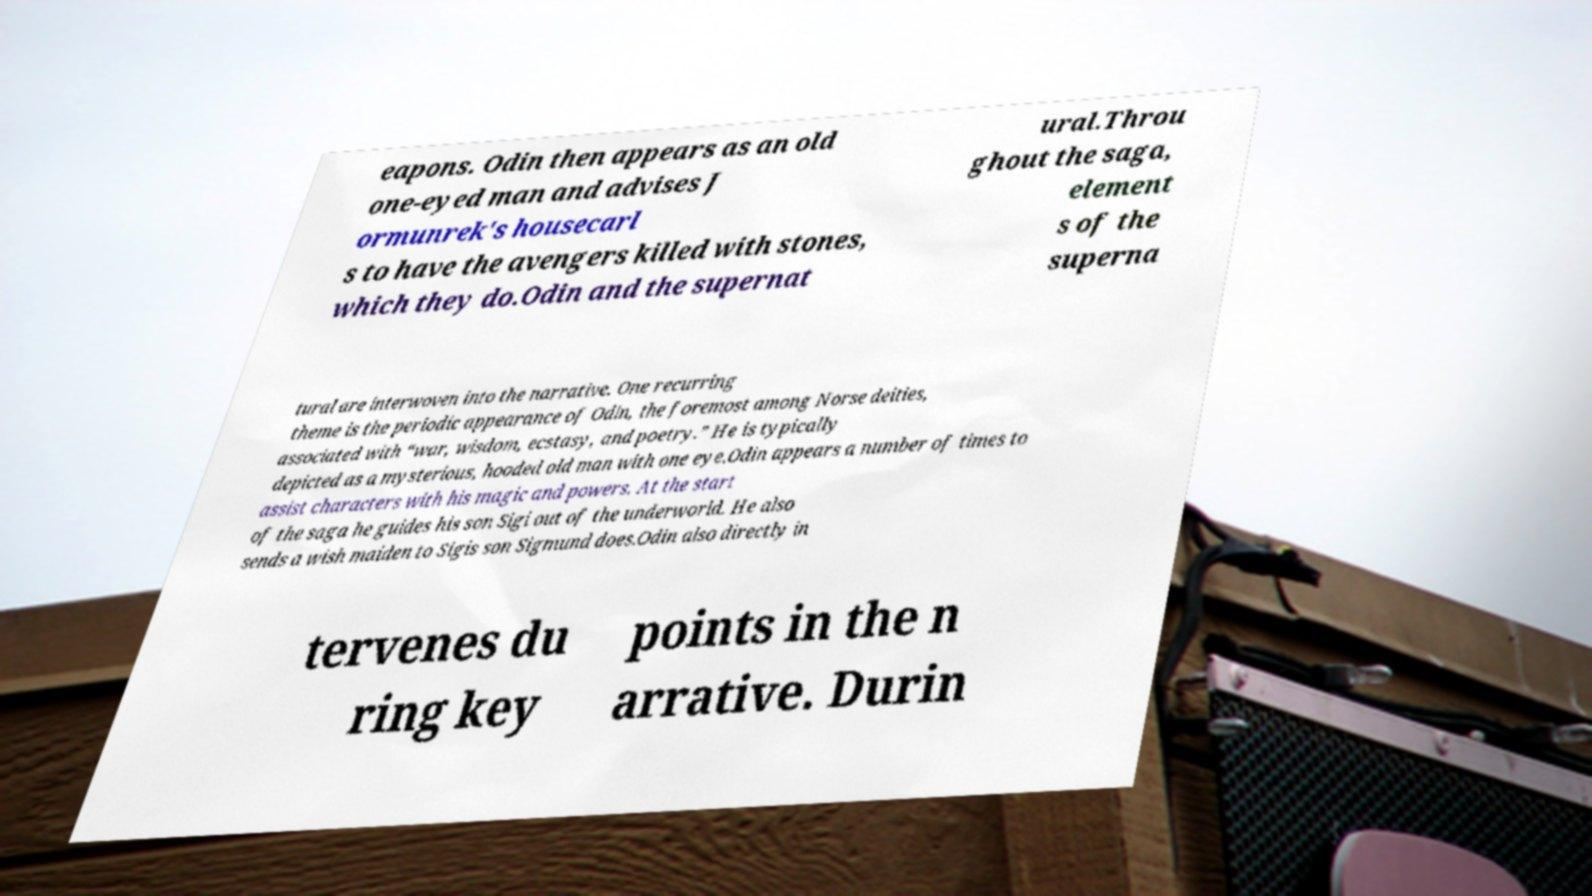For documentation purposes, I need the text within this image transcribed. Could you provide that? eapons. Odin then appears as an old one-eyed man and advises J ormunrek's housecarl s to have the avengers killed with stones, which they do.Odin and the supernat ural.Throu ghout the saga, element s of the superna tural are interwoven into the narrative. One recurring theme is the periodic appearance of Odin, the foremost among Norse deities, associated with “war, wisdom, ecstasy, and poetry.” He is typically depicted as a mysterious, hooded old man with one eye.Odin appears a number of times to assist characters with his magic and powers. At the start of the saga he guides his son Sigi out of the underworld. He also sends a wish maiden to Sigis son Sigmund does.Odin also directly in tervenes du ring key points in the n arrative. Durin 